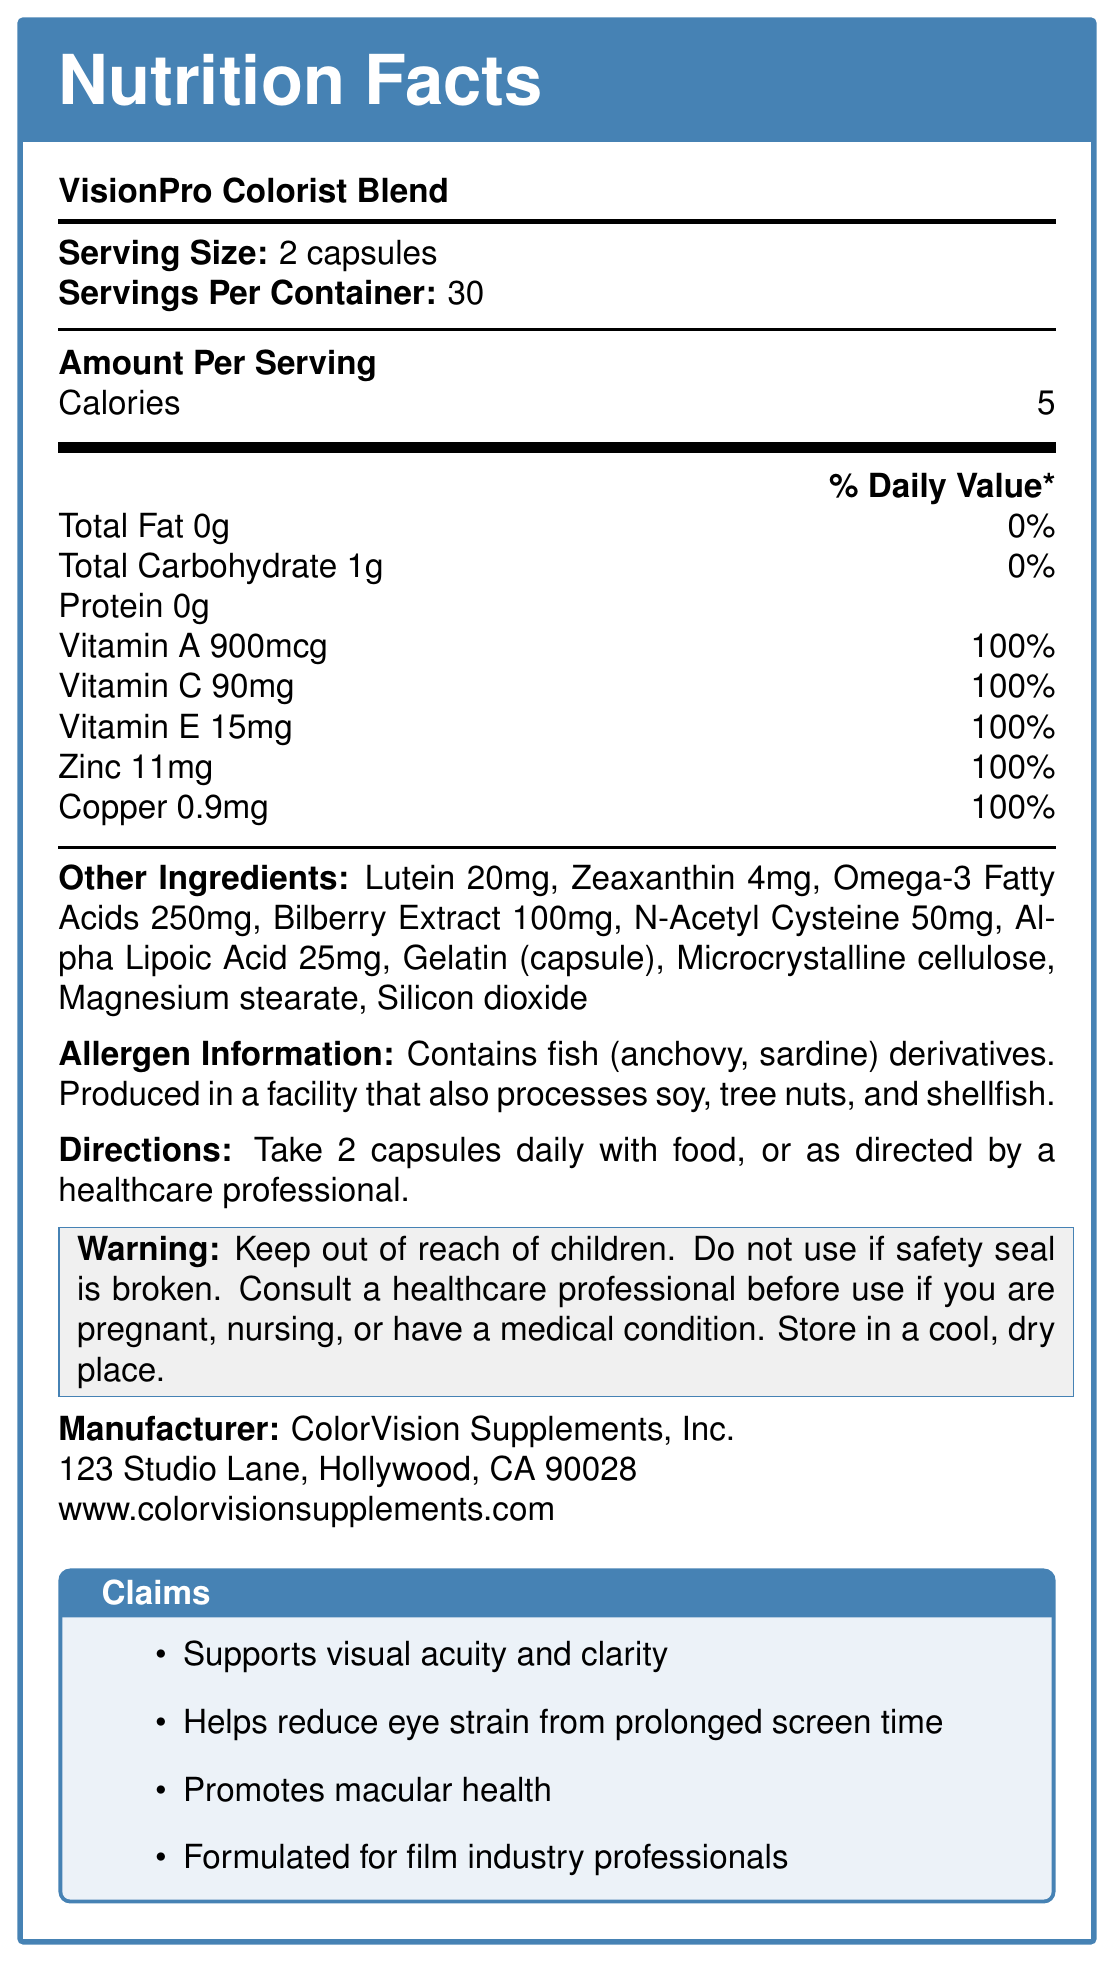What is the serving size of VisionPro Colorist Blend? The document states "Serving Size: 2 capsules".
Answer: 2 capsules How many servings are in one container? It is mentioned in the document under "Servings Per Container: 30".
Answer: 30 servings What is the amount of Vitamin A per serving and its daily value percentage? The document lists Vitamin A as "900mcg (100% DV)".
Answer: 900mcg, 100% DV What allergens are present in VisionPro Colorist Blend? The allergen information box specifies "Contains fish (anchovy, sardine) derivatives".
Answer: Fish (anchovy, sardine) derivatives What is the total amount of calories per serving? The document states under "Amount Per Serving" that there are 5 calories.
Answer: 5 calories Which ingredient is used to make the capsule of VisionPro Colorist Blend? A. Magnesium stearate B. Microcrystalline cellulose C. Gelatin D. Silicon dioxide The document lists "Gelatin (capsule)" under the other ingredients section.
Answer: C. Gelatin How should VisionPro Colorist Blend be stored? A. In a humid environment B. In a cool, dry place C. At temperatures above 30°C D. Under sunlight The warning section mentions "Store in a cool, dry place".
Answer: B. In a cool, dry place Can individuals who are pregnant use VisionPro Colorist Blend without professional consultation? Yes/No The document advises, "Consult a healthcare professional before use if you are pregnant, nursing, or have a medical condition."
Answer: No What key benefits does VisionPro Colorist Blend claim to provide? These claims are clearly listed at the bottom of the document.
Answer: Supports visual acuity and clarity, Helps reduce eye strain from prolonged screen time, Promotes macular health, Formulated for film industry professionals Where is VisionPro Colorist Blend manufactured? The manufacturer's address is provided in the document.
Answer: 123 Studio Lane, Hollywood, CA 90028 How often should VisionPro Colorist Blend be taken? The directions section specifies the dosage as "Take 2 capsules daily with food".
Answer: Take 2 capsules daily with food Which vitamin is not listed in the VisionPro Colorist Blend? A. Vitamin A B. Vitamin B C. Vitamin C D. Vitamin E The document lists Vitamins A, C, and E but does not mention Vitamin B.
Answer: B. Vitamin B Describe the main purpose of VisionPro Colorist Blend. The document provides nutritional information, key ingredients, claims, directions for use, allergen information, and warnings, all emphasizing its benefits for eye health tailored for professionals in the film industry.
Answer: The document details that VisionPro Colorist Blend is a vitamin supplement designed to support eye health, particularly catering to film industry professionals by improving visual acuity, reducing eye strain from prolonged screen time, and promoting macular health. What is the origin of the Omega-3 Fatty Acids listed in the supplement? The document lists "Omega-3 Fatty Acids 250mg" but does not provide information about their origin or source.
Answer: Not enough information 